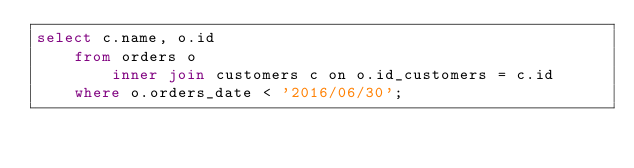Convert code to text. <code><loc_0><loc_0><loc_500><loc_500><_SQL_>select c.name, o.id
    from orders o
        inner join customers c on o.id_customers = c.id
    where o.orders_date < '2016/06/30';</code> 